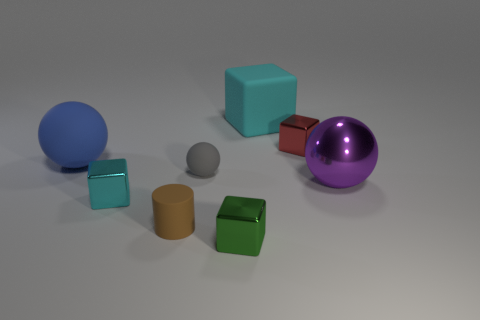Subtract all metal cubes. How many cubes are left? 1 Add 2 blue objects. How many objects exist? 10 Subtract 1 cylinders. How many cylinders are left? 0 Subtract all red blocks. How many blocks are left? 3 Subtract all cylinders. How many objects are left? 7 Add 4 big metallic things. How many big metallic things are left? 5 Add 5 cyan matte blocks. How many cyan matte blocks exist? 6 Subtract 0 purple blocks. How many objects are left? 8 Subtract all purple cylinders. Subtract all red blocks. How many cylinders are left? 1 Subtract all gray cylinders. How many purple spheres are left? 1 